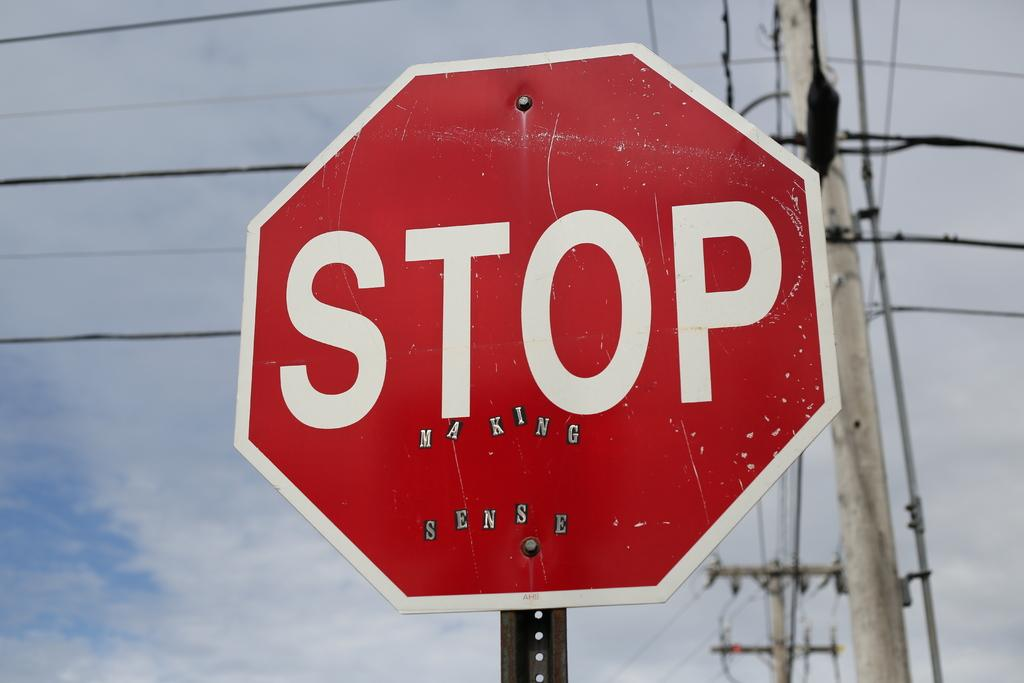<image>
Create a compact narrative representing the image presented. a stop sign that is next to a telephone pole 